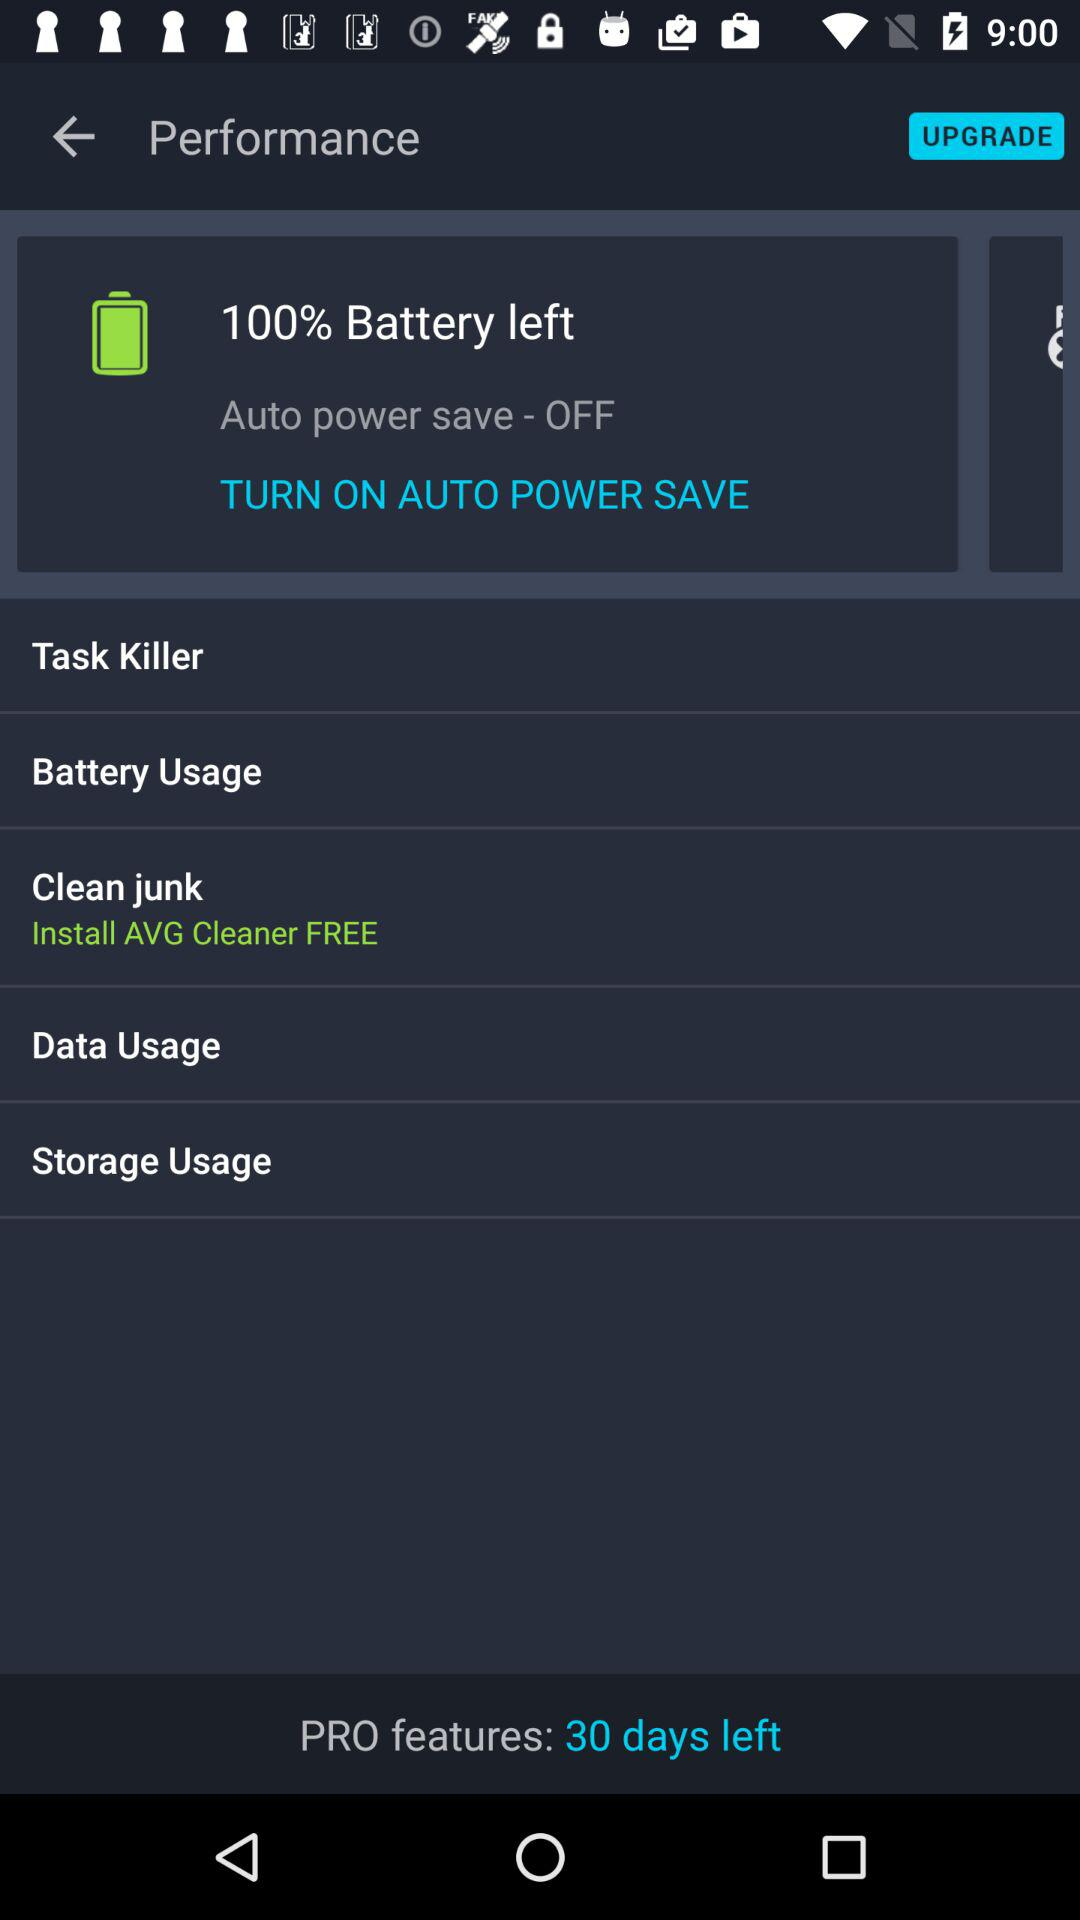How many days are left for the "PRO features"? There are 30 days left. 